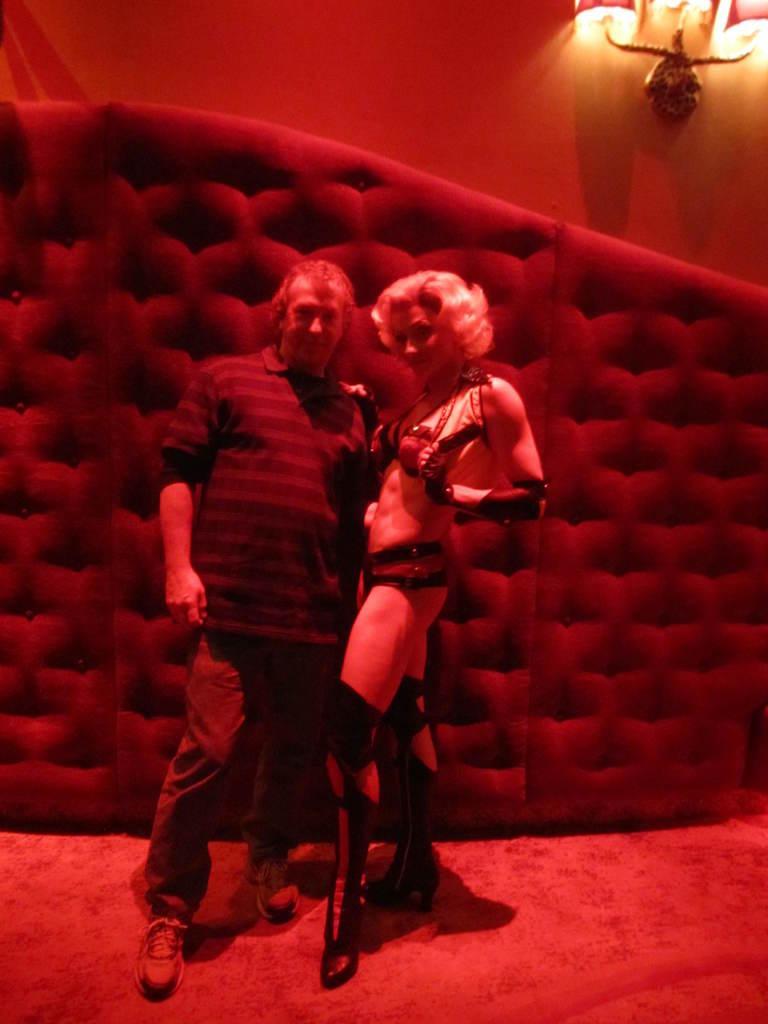Please provide a concise description of this image. In this image we can see a man and a woman standing on the floor. In the background we can see the wall and also the lights. 